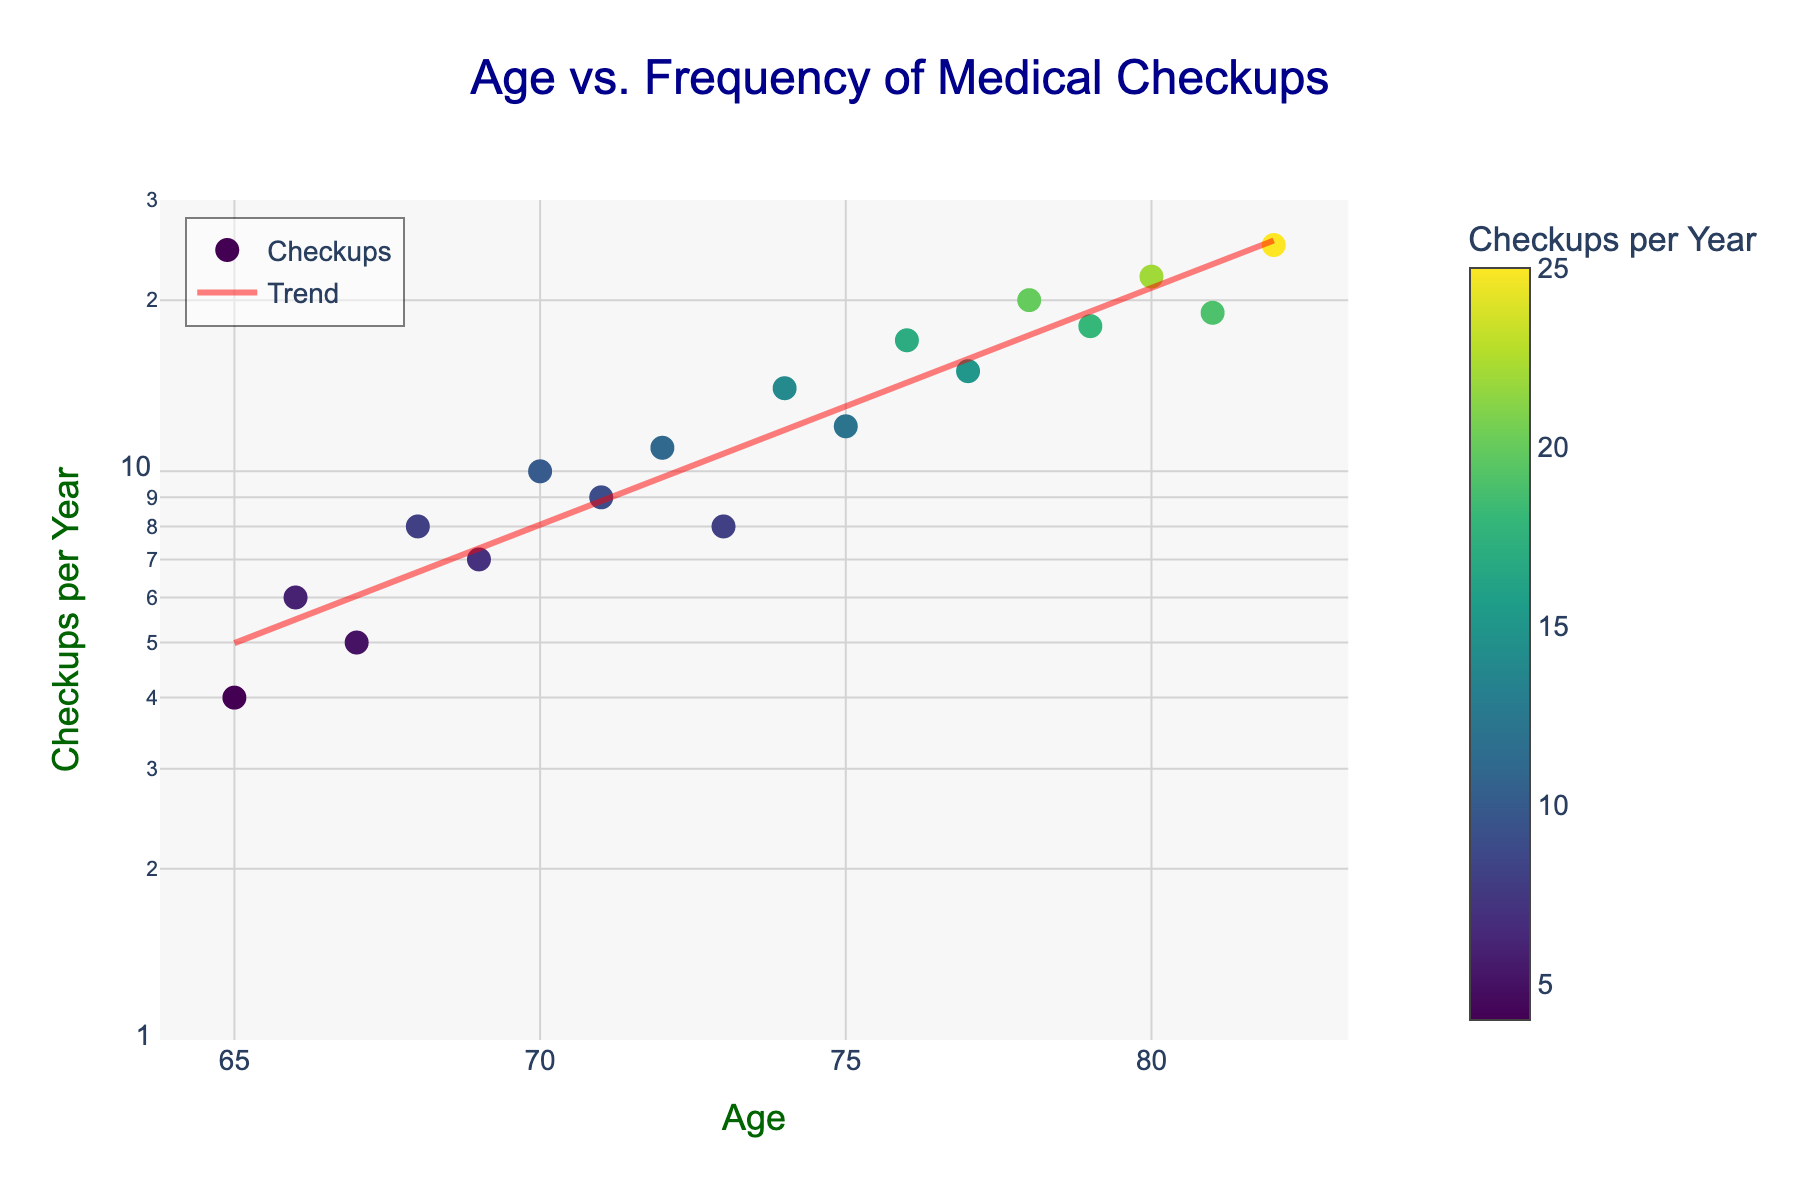What is the title of the scatter plot? The title is displayed prominently at the top of the scatter plot.
Answer: Age vs. Frequency of Medical Checkups What does the color of the markers represent? The color of the markers corresponds to the frequency of checkups per year, as indicated by the color scale on the right side of the plot.
Answer: The frequency of checkups per year How many data points are shown in the scatter plot? The plot contains one marker for each row in the data, representing the pair (Age, Frequency_of_Checkups_Per_Year). Providing a sum of these data points will answer the question.
Answer: 18 What is the highest frequency of checkups per year shown in the chart, and at what age does it occur? By examining the vertical axis and identifying the highest point, and then checking its corresponding age on the horizontal axis provides the needed values.
Answer: 25 at age 82 How does the trend of checkups per year change as age increases? Analyzing the red trend line that incorporates the logarithmic relationship between age and frequency of checkups will provide insight into the overall pattern.
Answer: Frequency of checkups increases with age What is the average frequency of checkups per year for individuals aged 75 to 80? Sum the frequency of checkups for ages 75, 76, 77, 78, 79, and 80, then divide by 6. (12+17+15+20+18+22) / 6 = 104 / 6 = 17.33
Answer: 17.33 Does the frequency of checkups per year increase linearly with age? The presence of a logarithmic scale on the y-axis suggests a need for analysis beyond a strictly linear relationship; observing the curved trend line and interpreting its logarithmic nature answers this.
Answer: No Which age has the closest frequency of checkups to 10 per year? Locate the marker nearest to the value 10 on the vertical axis and then find the corresponding age on the horizontal axis.
Answer: Age 70 By how much does the frequency of checkups increase from age 65 to age 80? Identify the frequency values at ages 65 and 80, then compute the difference (22 - 4).
Answer: 18 What is the frequency of checkups per year at age 74? Identify the marker at age 74 on the horizontal axis, then read the corresponding frequency on the vertical axis.
Answer: 14 